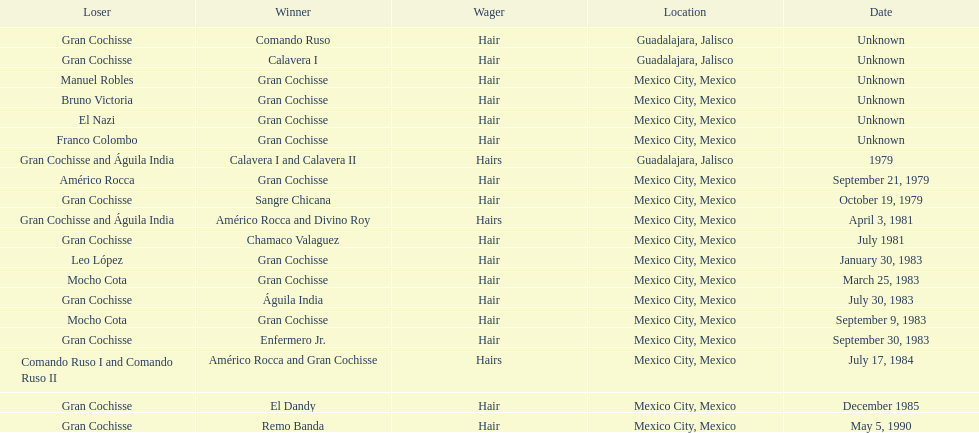How many times has gran cochisse been a winner? 9. 